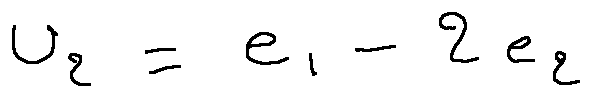Convert formula to latex. <formula><loc_0><loc_0><loc_500><loc_500>u _ { 2 } = e _ { 1 } - 2 e _ { 2 }</formula> 